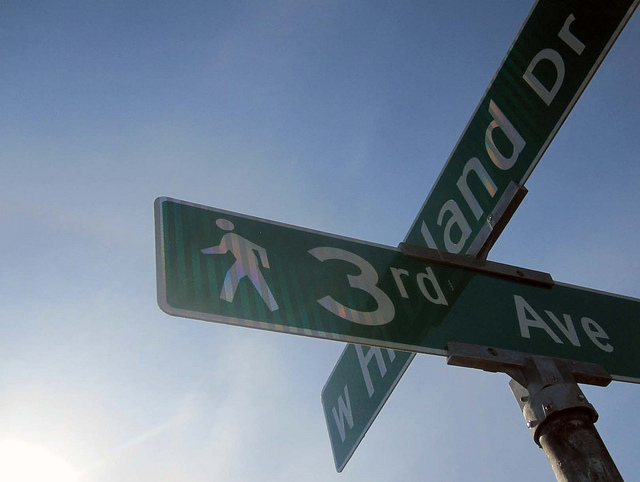Read all the text in this image. Ave DR and 3 rd H W 